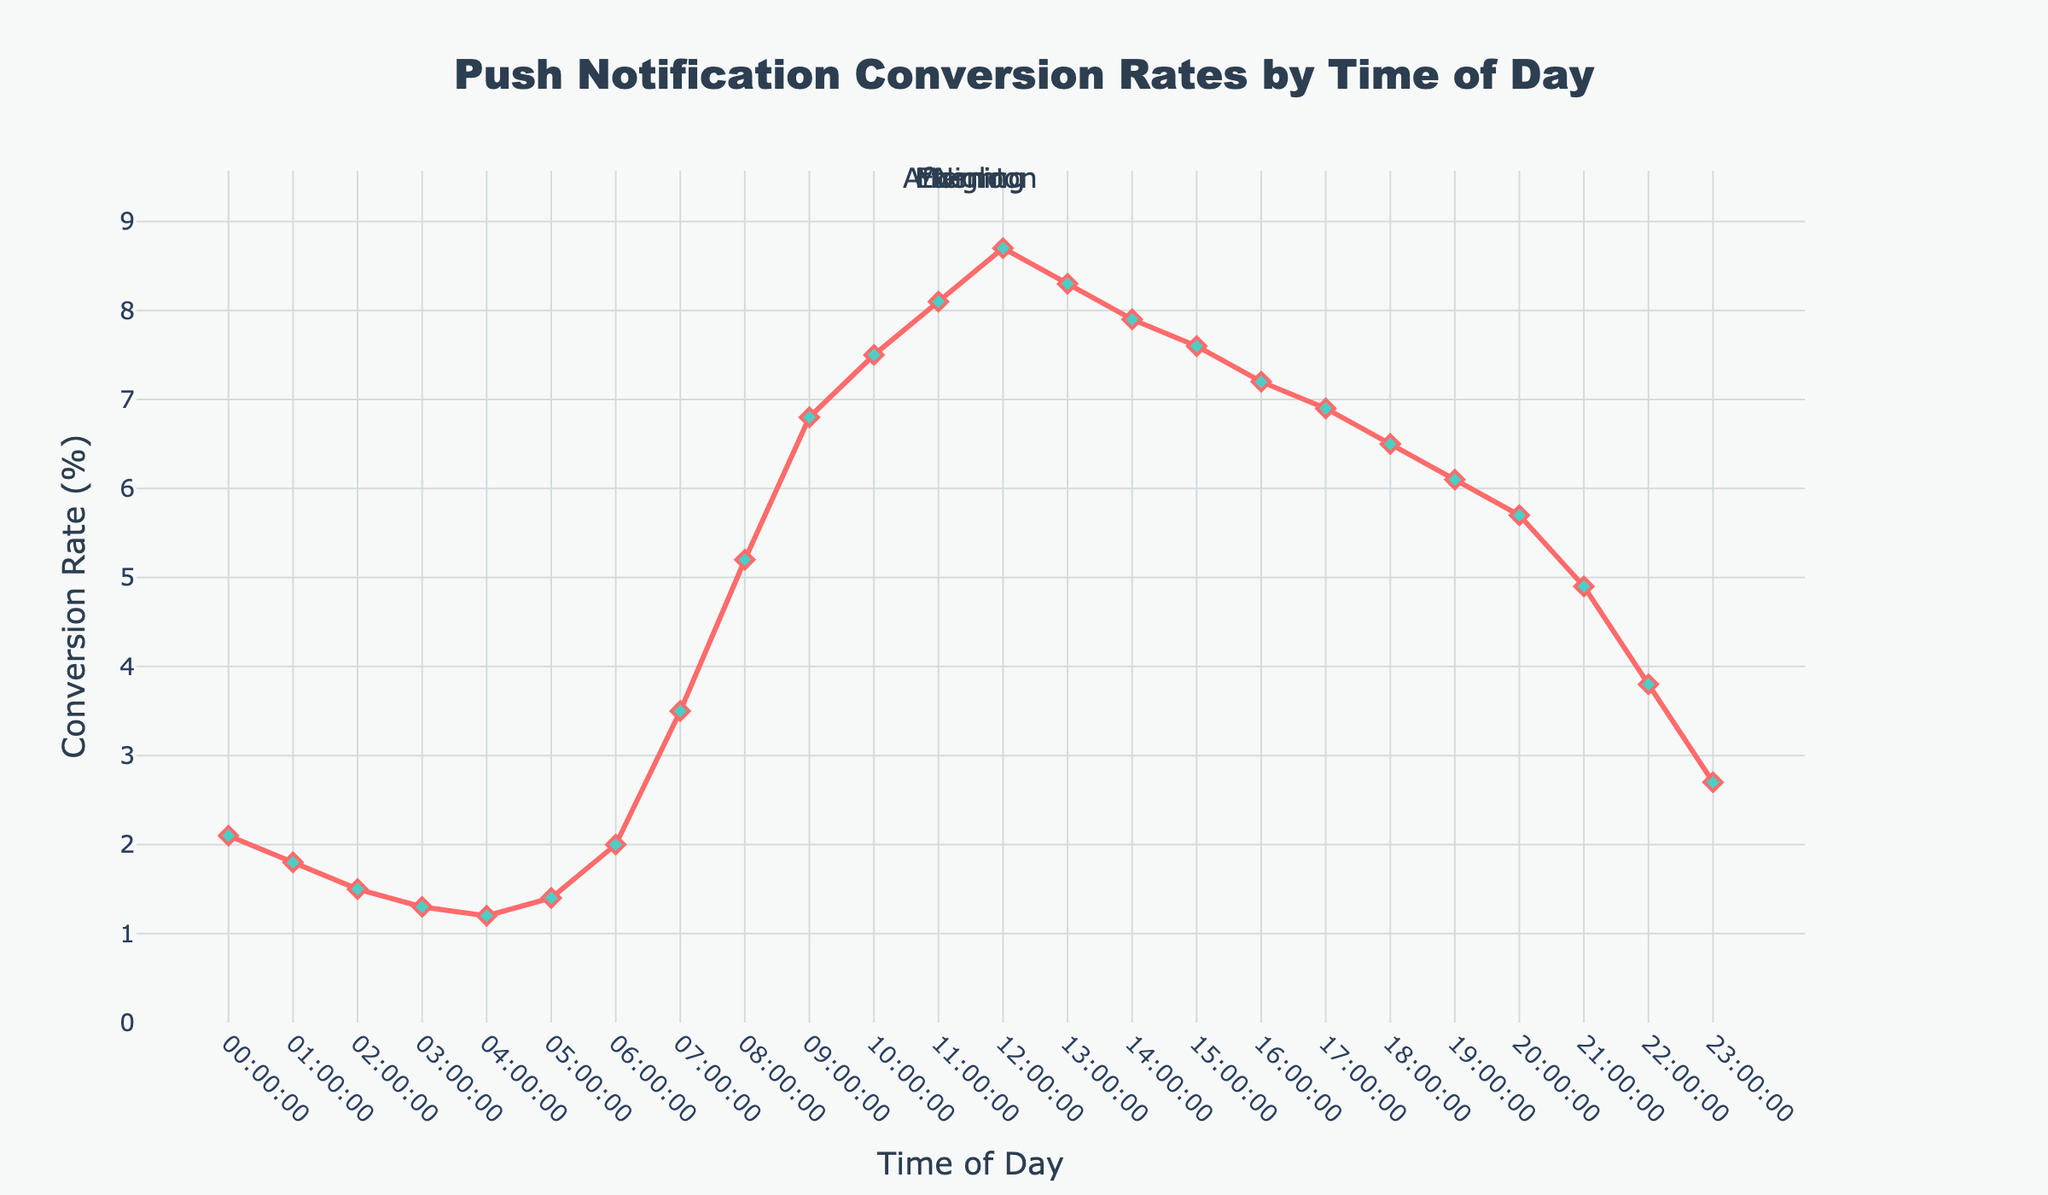What time period has the highest conversion rate? The highest conversion rate is observed by looking at the peak point on the line chart, which occurs around 12:00 PM.
Answer: 12:00 PM How does the conversion rate at 03:00 compare to the conversion rate at 15:00? At 03:00, the conversion rate is 1.3%, and at 15:00, it is 7.6%. Therefore, the conversion rate at 15:00 is higher compared to 03:00.
Answer: 15:00 has a higher conversion rate What is the average conversion rate between 06:00 and 09:00? To find the average, add the conversion rates at 06:00 (2.0), 07:00 (3.5), 08:00 (5.2), and 09:00 (6.8) and then divide by 4. (2.0 + 3.5 + 5.2 + 6.8) / 4 = 17.5 / 4 = 4.375.
Answer: 4.375% Which period has a lower conversion rate, the morning (06:00-12:00) or evening (18:00-23:00)? To determine this, calculate the average conversion rates for each period. Morning average: (2.0+3.5+5.2+6.8+7.5+8.1) / 6 = 33.1 / 6 = 5.52. Evening average: (6.5+6.1+5.7+4.9+3.8+2.7) / 6 = 29.7 / 6 = 4.95. The evening period has a lower average conversion rate.
Answer: Evening What is the difference in conversion rate between the highest and lowest points throughout the day? The highest conversion rate is 8.7% at 12:00, and the lowest is 1.2% at 04:00. The difference is 8.7 - 1.2 = 7.5%.
Answer: 7.5% Does the conversion rate generally increase or decrease from midnight to noon? Observing the line chart, we can see that the conversion rate generally increases from 00:00 to 12:00, reaching a peak around noon.
Answer: Increase Which has a steeper rise in conversion rate, the period from 07:00 to 09:00 or the period from 16:00 to 18:00? To determine which period has a steeper rise, calculate the change in conversion rates. 07:00 to 09:00: 6.8 - 3.5 = 3.3. 16:00 to 18:00: 6.5 - 7.2 = -0.7. The period from 07:00 to 09:00 has a steeper rise.
Answer: 07:00 to 09:00 What conversion rate corresponds to the visual attribute of the largest green marker? The green markers with diamonds indicate conversion rates, with the largest one corresponding to the highest conversion rate, which is 8.7% around 12:00 PM.
Answer: 8.7% Which color-shaded area represents the highest conversion rate? The graph uses color shading for different times of day. The highest conversion rate of 8.7% occurs in the yellow-shaded morning area.
Answer: Yellow (morning) 